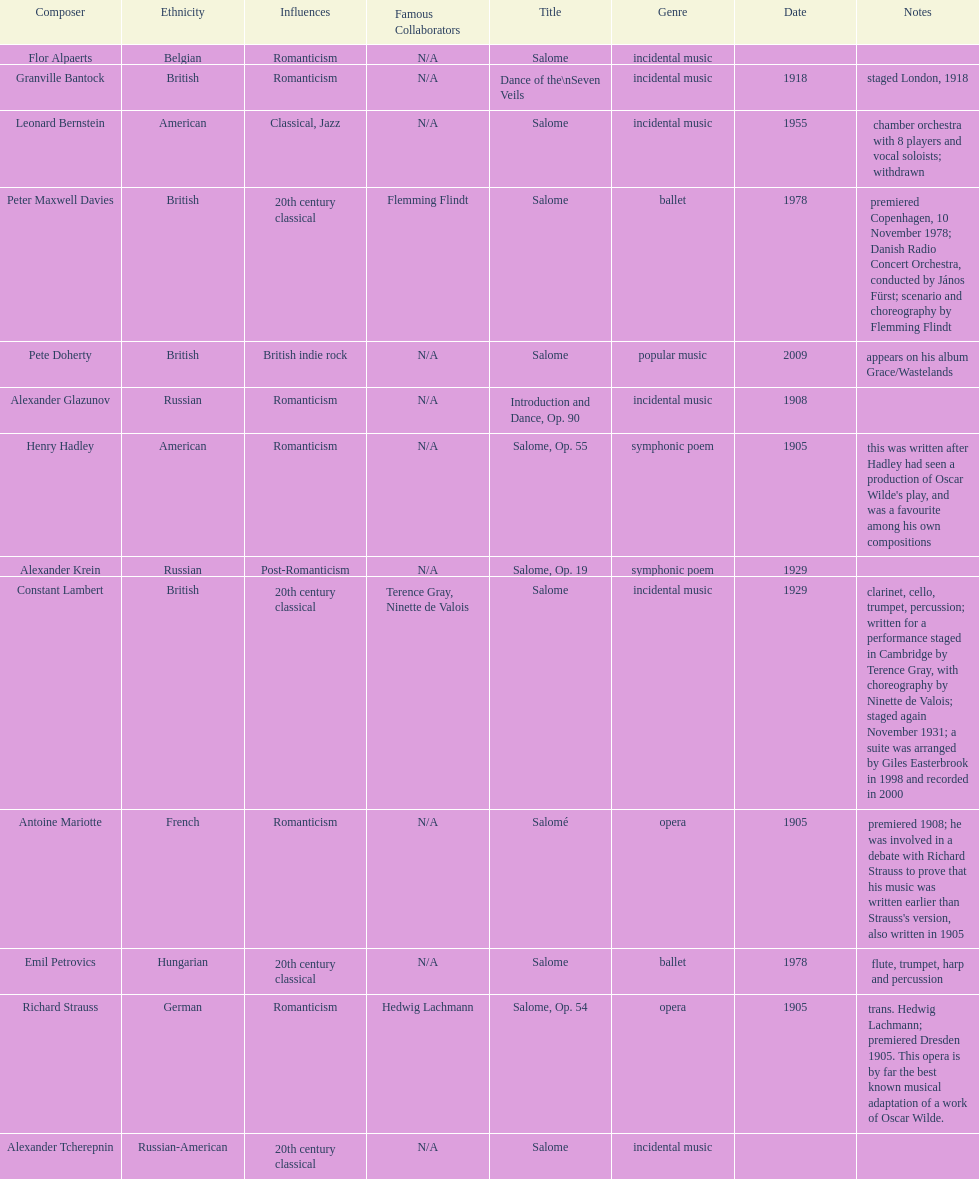Which composer is listed below pete doherty? Alexander Glazunov. 